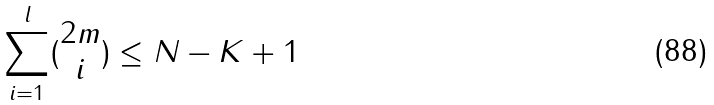Convert formula to latex. <formula><loc_0><loc_0><loc_500><loc_500>\sum _ { i = 1 } ^ { l } ( \begin{matrix} 2 m \\ i \end{matrix} ) \leq N - K + 1</formula> 